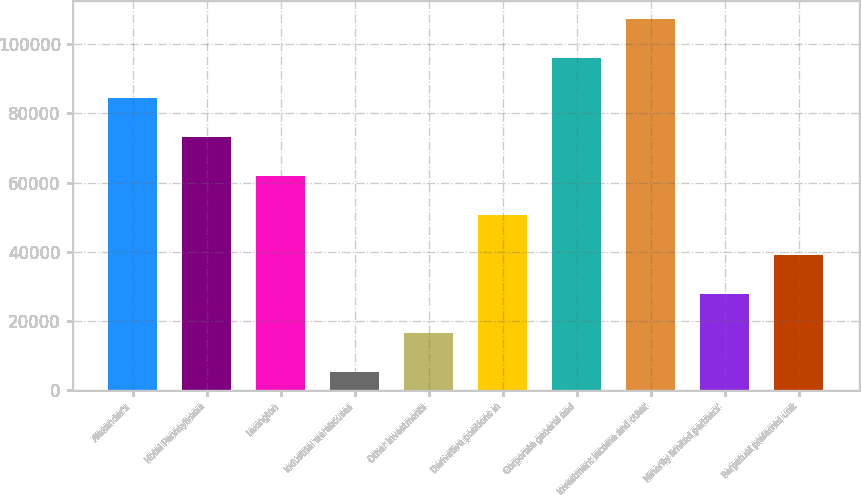Convert chart. <chart><loc_0><loc_0><loc_500><loc_500><bar_chart><fcel>Alexander's<fcel>Hotel Pennsylvania<fcel>Lexington<fcel>Industrial warehouses<fcel>Other investments<fcel>Derivative positions in<fcel>Corporate general and<fcel>Investment income and other<fcel>Minority limited partners'<fcel>Perpetual preferred unit<nl><fcel>84543.9<fcel>73218.2<fcel>61892.5<fcel>5264<fcel>16589.7<fcel>50566.8<fcel>95869.6<fcel>107195<fcel>27915.4<fcel>39241.1<nl></chart> 